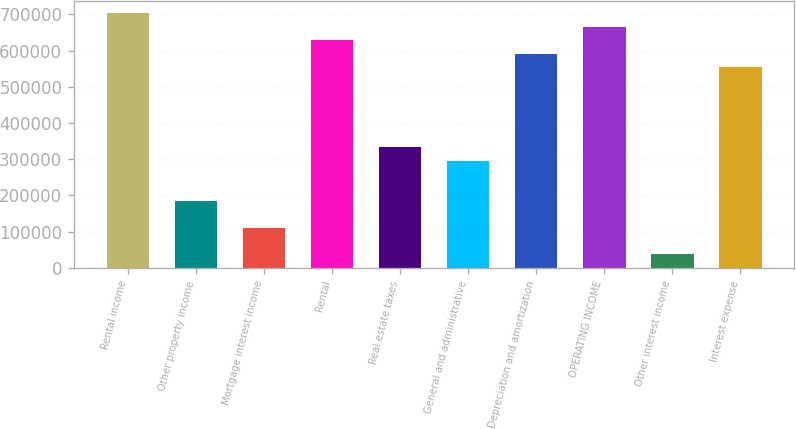Convert chart to OTSL. <chart><loc_0><loc_0><loc_500><loc_500><bar_chart><fcel>Rental income<fcel>Other property income<fcel>Mortgage interest income<fcel>Rental<fcel>Real estate taxes<fcel>General and administrative<fcel>Depreciation and amortization<fcel>OPERATING INCOME<fcel>Other interest income<fcel>Interest expense<nl><fcel>703130<fcel>185035<fcel>111021<fcel>629117<fcel>333062<fcel>296055<fcel>592110<fcel>666123<fcel>37007.8<fcel>555103<nl></chart> 